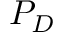<formula> <loc_0><loc_0><loc_500><loc_500>P _ { D }</formula> 